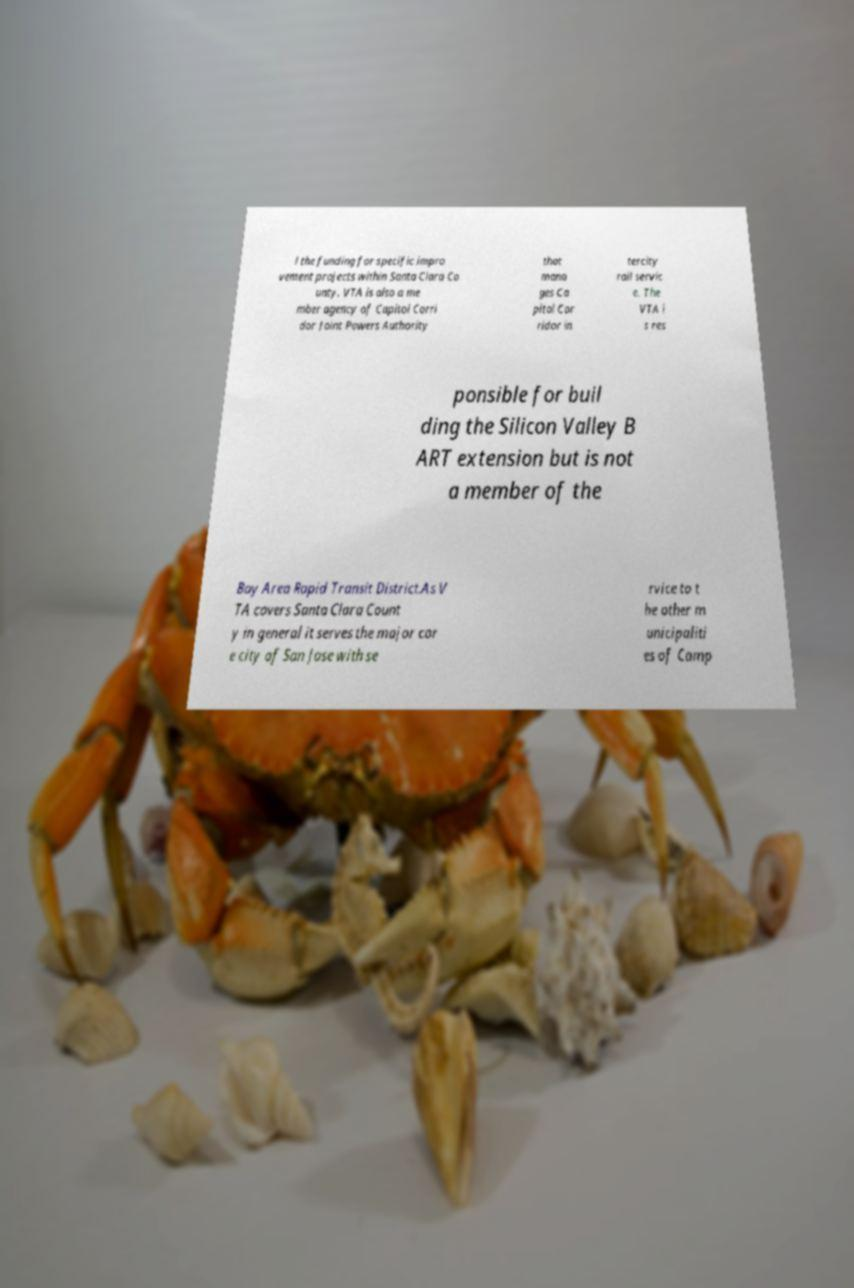I need the written content from this picture converted into text. Can you do that? l the funding for specific impro vement projects within Santa Clara Co unty. VTA is also a me mber agency of Capitol Corri dor Joint Powers Authority that mana ges Ca pitol Cor ridor in tercity rail servic e. The VTA i s res ponsible for buil ding the Silicon Valley B ART extension but is not a member of the Bay Area Rapid Transit District.As V TA covers Santa Clara Count y in general it serves the major cor e city of San Jose with se rvice to t he other m unicipaliti es of Camp 